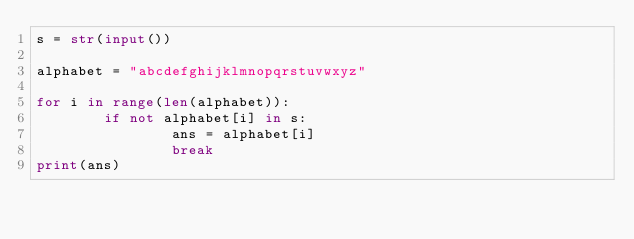Convert code to text. <code><loc_0><loc_0><loc_500><loc_500><_Python_>s = str(input())
     
alphabet = "abcdefghijklmnopqrstuvwxyz"
     
for i in range(len(alphabet)):
        if not alphabet[i] in s:
                ans = alphabet[i]
                break
print(ans)</code> 